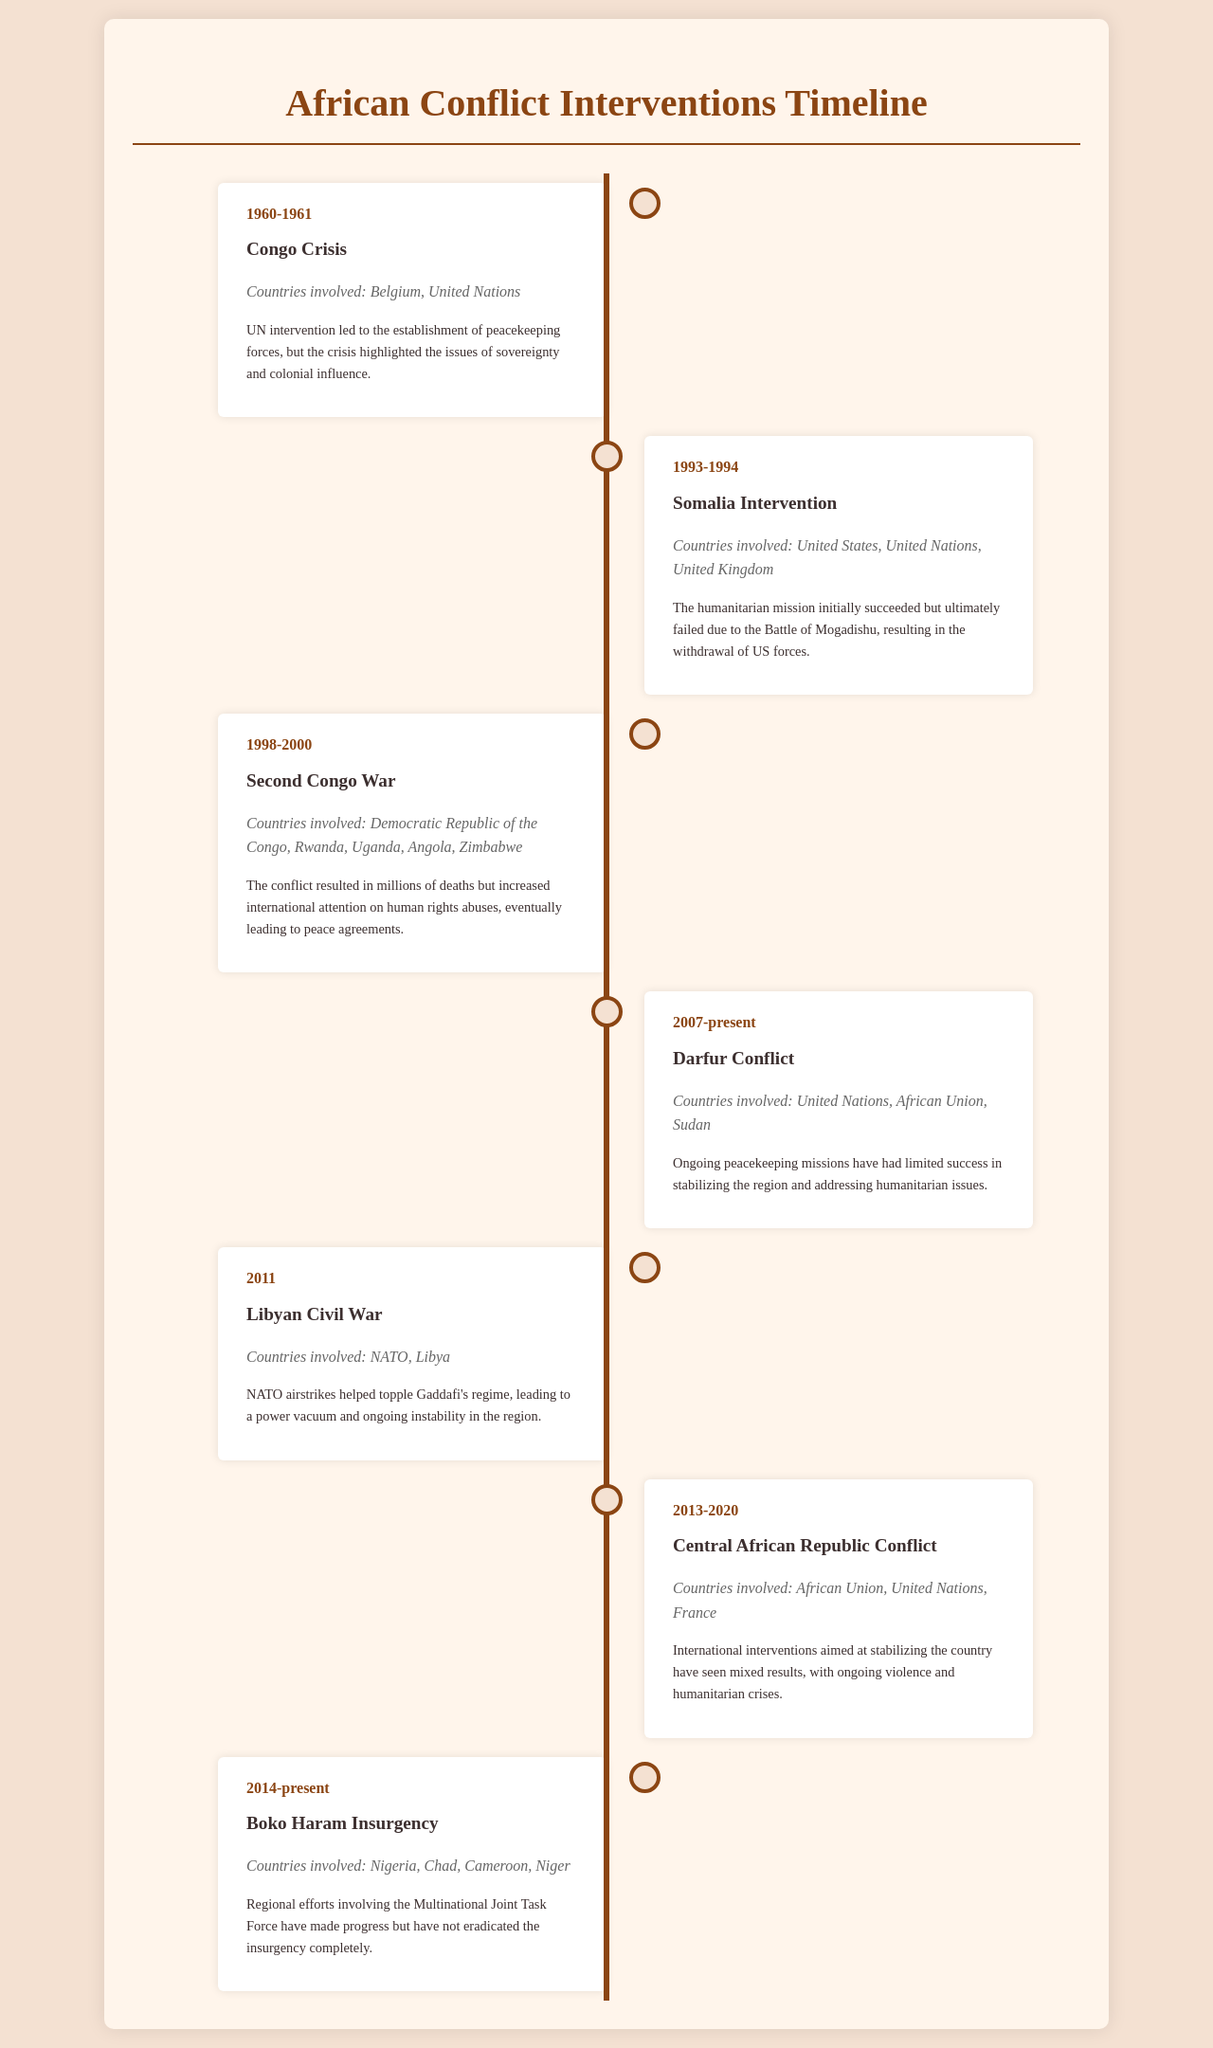What is the date of the Congo Crisis? The document lists the date range for the Congo Crisis as 1960-1961.
Answer: 1960-1961 What countries were involved in the Somalia Intervention? The document states that the countries involved were the United States, United Nations, and United Kingdom.
Answer: United States, United Nations, United Kingdom What was the outcome of the Second Congo War? According to the document, the outcome noted that millions of deaths occurred but increased international attention on human rights abuses.
Answer: Millions of deaths, increased international attention on human rights abuses What ongoing conflict is mentioned as occurring from 2007 to the present? The timeline lists the Darfur Conflict as the ongoing conflict during this period.
Answer: Darfur Conflict How many different countries are mentioned in the Boko Haram Insurgency? The document refers to four countries involved: Nigeria, Chad, Cameroon, and Niger.
Answer: Four Which international organization was involved in the Central African Republic Conflict? The document specifies that the African Union was one of the organizations involved.
Answer: African Union What was one effect of NATO airstrikes in the Libyan Civil War? The document indicates that NATO airstrikes helped to topple Gaddafi's regime, leading to a power vacuum.
Answer: Power vacuum Which conflict began in 2014 and is still ongoing? The timeline notes the Boko Haram Insurgency as starting in 2014 and continuing to the present.
Answer: Boko Haram Insurgency 